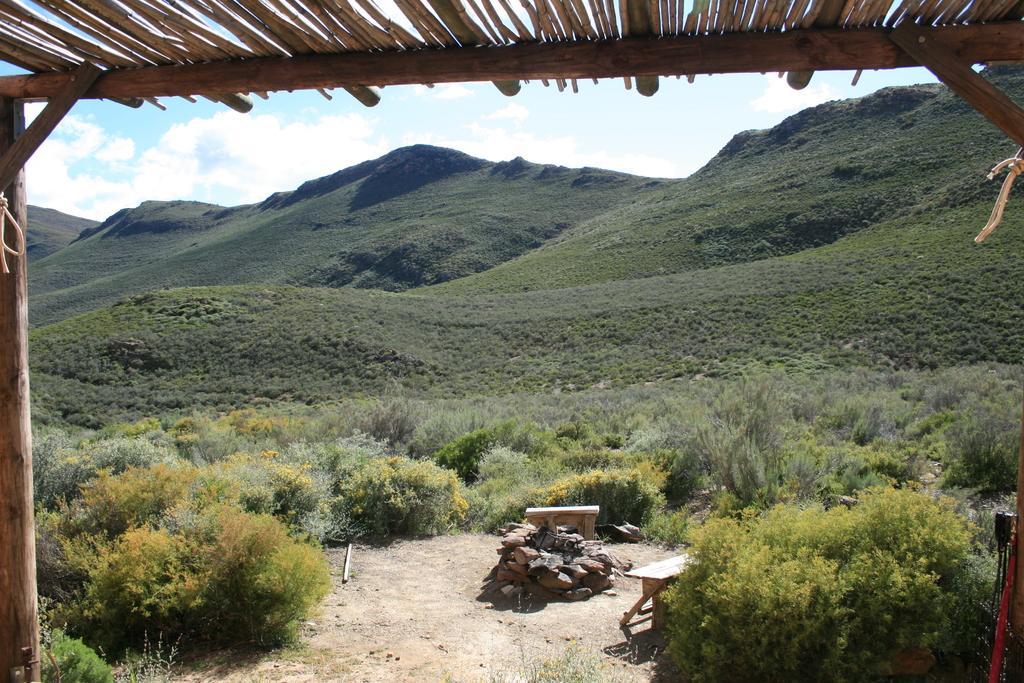In one or two sentences, can you explain what this image depicts? In this image in the background there are some mountains, at the bottom there are some plants and wooden sticks. On the top of the image there is a wooden pole and wooden sticks, at the bottom there is sand and on the top of the image there is sky. 